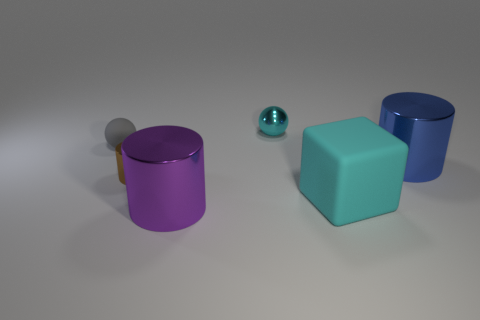What is the blue object made of?
Give a very brief answer. Metal. There is a shiny cylinder in front of the brown thing; is it the same size as the tiny gray matte object?
Your response must be concise. No. There is a metallic thing that is both to the left of the blue metal cylinder and on the right side of the purple thing; what size is it?
Your answer should be very brief. Small. There is a rubber thing that is on the right side of the small cyan shiny sphere; is it the same color as the small metallic ball?
Your answer should be very brief. Yes. What number of things are big cylinders that are in front of the big cube or tiny spheres?
Provide a short and direct response. 3. What is the material of the tiny sphere that is to the left of the large metal thing that is in front of the big cylinder behind the big cyan cube?
Make the answer very short. Rubber. Are there more large metal cylinders in front of the brown shiny cylinder than cubes behind the tiny cyan shiny object?
Keep it short and to the point. Yes. How many spheres are either small cyan rubber objects or large cyan things?
Offer a terse response. 0. What number of tiny spheres are in front of the tiny brown shiny thing to the left of the cyan object in front of the tiny metal cylinder?
Your response must be concise. 0. There is a large cube that is the same color as the shiny sphere; what is its material?
Give a very brief answer. Rubber. 